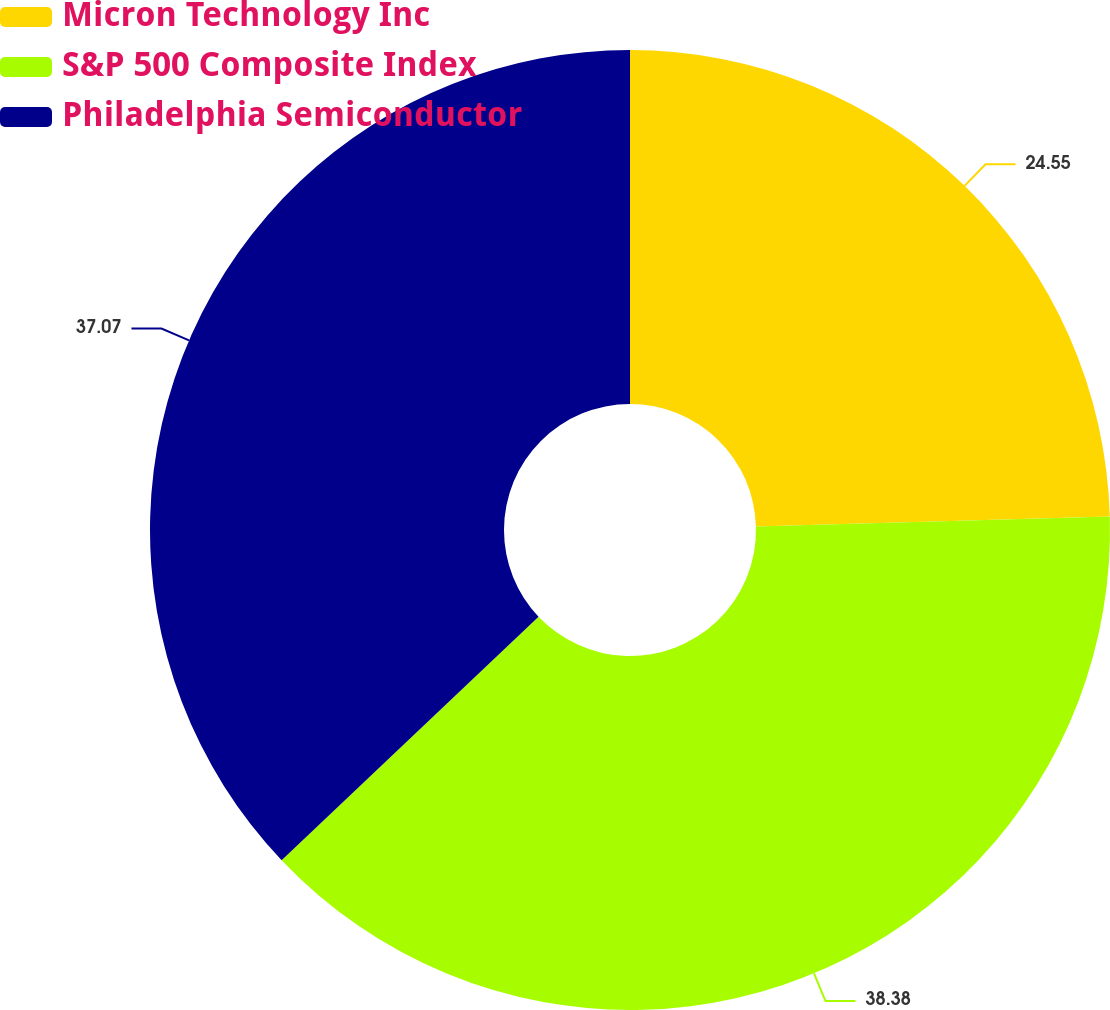<chart> <loc_0><loc_0><loc_500><loc_500><pie_chart><fcel>Micron Technology Inc<fcel>S&P 500 Composite Index<fcel>Philadelphia Semiconductor<nl><fcel>24.55%<fcel>38.37%<fcel>37.07%<nl></chart> 